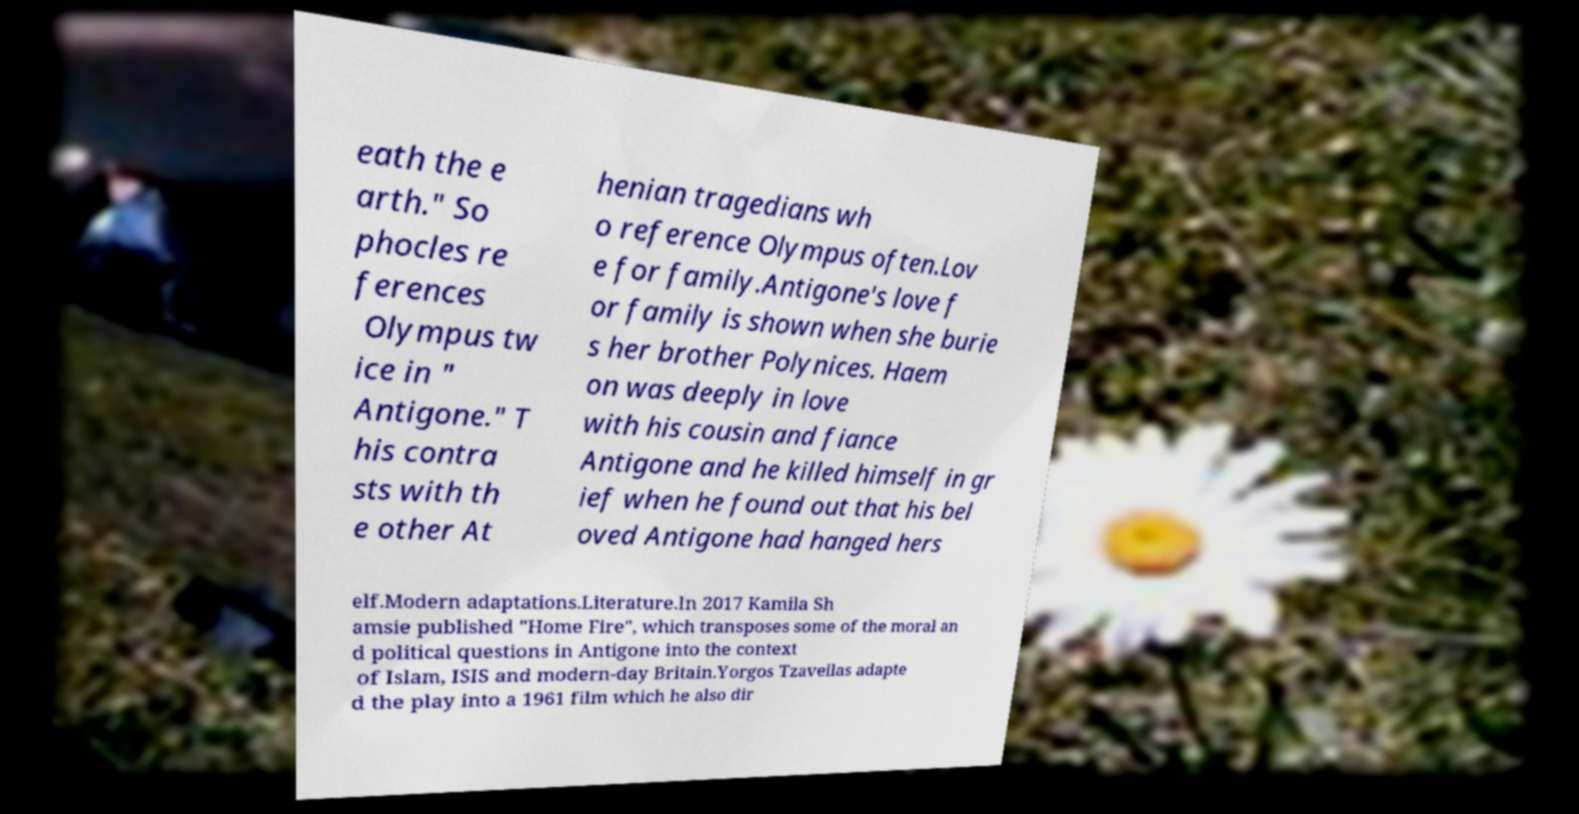For documentation purposes, I need the text within this image transcribed. Could you provide that? eath the e arth." So phocles re ferences Olympus tw ice in " Antigone." T his contra sts with th e other At henian tragedians wh o reference Olympus often.Lov e for family.Antigone's love f or family is shown when she burie s her brother Polynices. Haem on was deeply in love with his cousin and fiance Antigone and he killed himself in gr ief when he found out that his bel oved Antigone had hanged hers elf.Modern adaptations.Literature.In 2017 Kamila Sh amsie published "Home Fire", which transposes some of the moral an d political questions in Antigone into the context of Islam, ISIS and modern-day Britain.Yorgos Tzavellas adapte d the play into a 1961 film which he also dir 